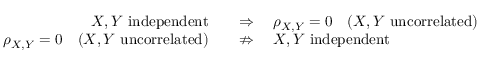<formula> <loc_0><loc_0><loc_500><loc_500>{ \begin{array} { r l } { X , Y { i n d e p e n d e n t } \quad } & { \Rightarrow \quad \rho _ { X , Y } = 0 \quad ( X , Y { u n c o r r e l a t e d } ) } \\ { \rho _ { X , Y } = 0 \quad ( X , Y { u n c o r r e l a t e d } ) \quad } & { \ n R i g h t a r r o w \quad X , Y { i n d e p e n d e n t } } \end{array} }</formula> 